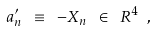Convert formula to latex. <formula><loc_0><loc_0><loc_500><loc_500>a ^ { \prime } _ { n } \ \equiv \ - X _ { n } \ \in \ { R } ^ { 4 } \ ,</formula> 